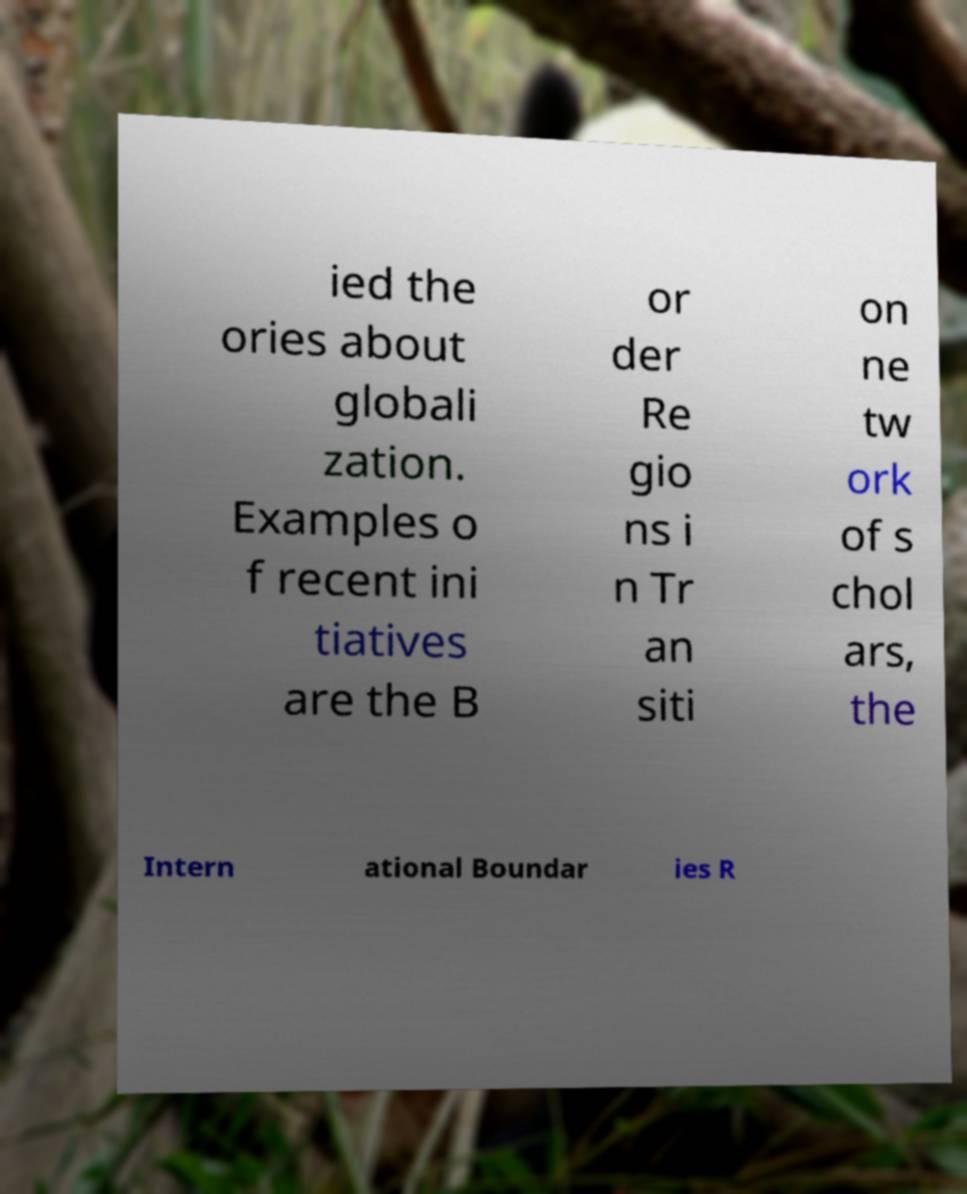For documentation purposes, I need the text within this image transcribed. Could you provide that? ied the ories about globali zation. Examples o f recent ini tiatives are the B or der Re gio ns i n Tr an siti on ne tw ork of s chol ars, the Intern ational Boundar ies R 